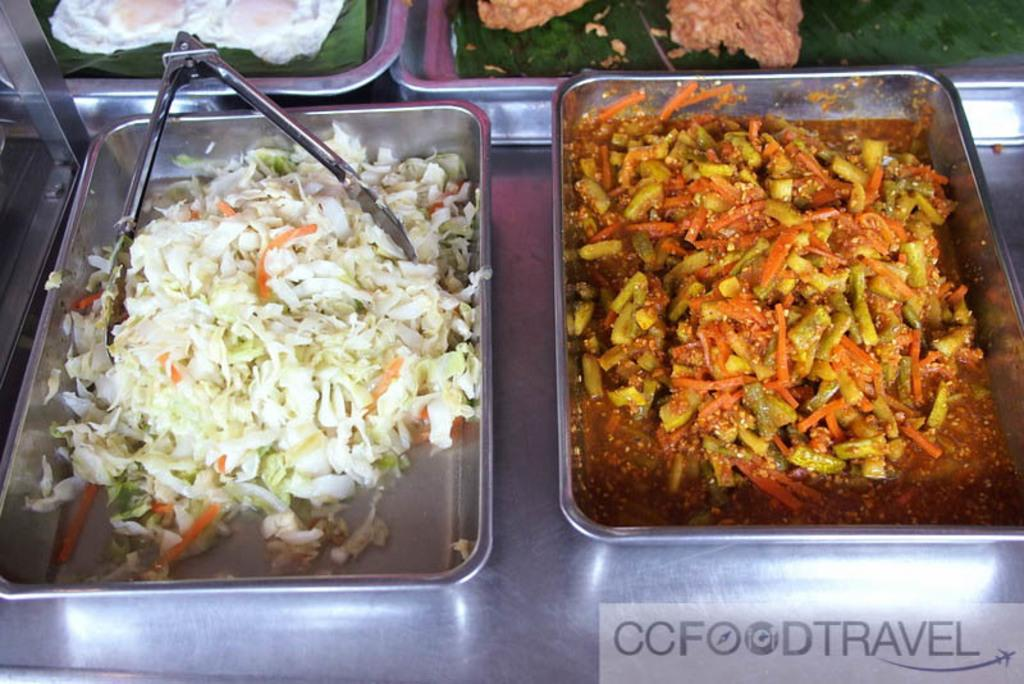What is present in the trays in the image? There are food items in the trays. What object is used to hold something in the image? There is a holder in the image. Where is the holder placed? The holder is placed on a stand. What information can be found at the bottom of the image? There is text visible at the bottom of the image. What type of authority figure can be seen in the image? There is no authority figure present in the image. Can you describe the patch on the boat in the image? There is no boat or patch present in the image. 